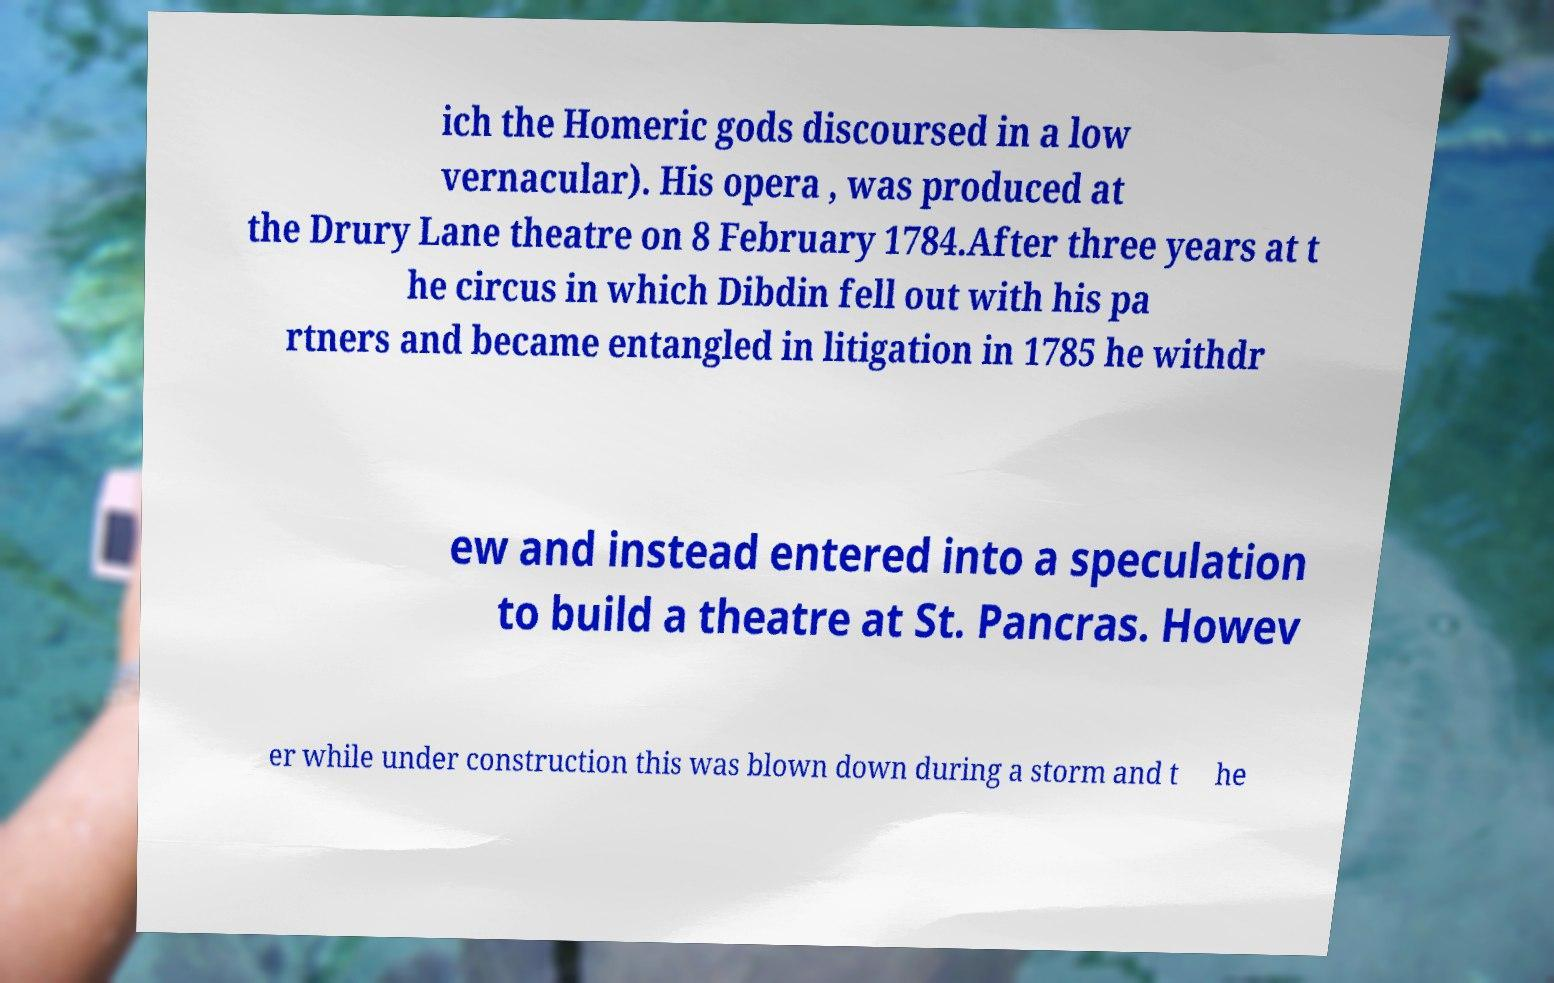Could you assist in decoding the text presented in this image and type it out clearly? ich the Homeric gods discoursed in a low vernacular). His opera , was produced at the Drury Lane theatre on 8 February 1784.After three years at t he circus in which Dibdin fell out with his pa rtners and became entangled in litigation in 1785 he withdr ew and instead entered into a speculation to build a theatre at St. Pancras. Howev er while under construction this was blown down during a storm and t he 